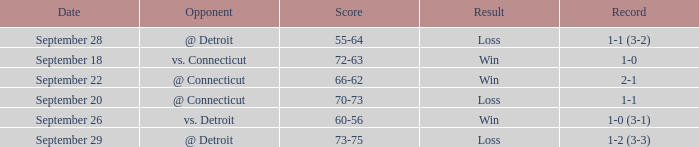WHAT IS THE OPPONENT WITH A SCORE OF 72-63? Vs. connecticut. 